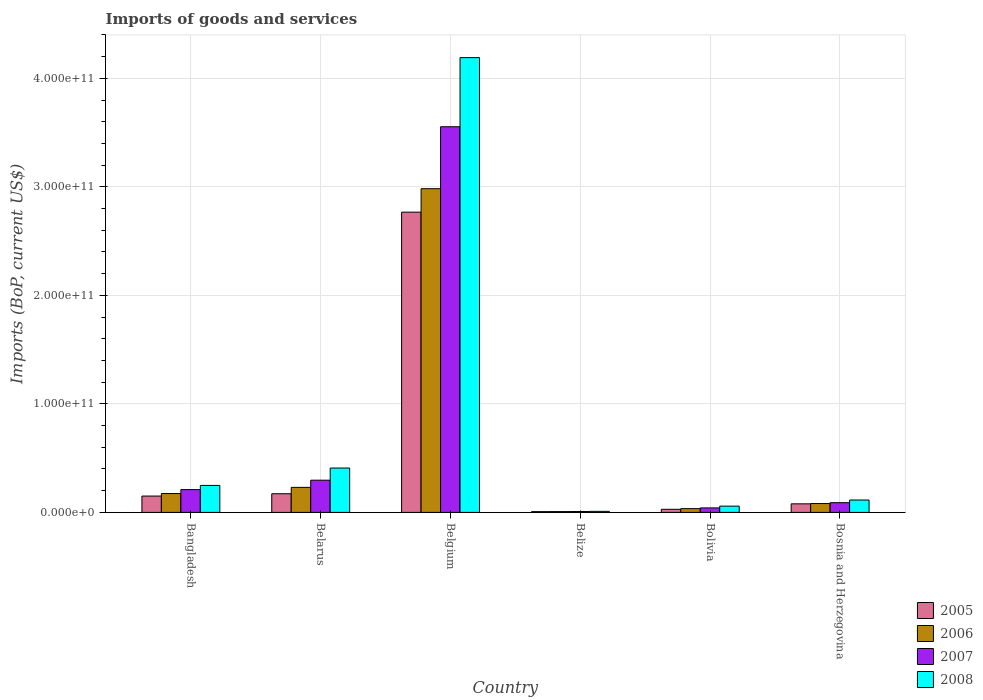How many different coloured bars are there?
Offer a very short reply. 4. Are the number of bars per tick equal to the number of legend labels?
Give a very brief answer. Yes. In how many cases, is the number of bars for a given country not equal to the number of legend labels?
Offer a very short reply. 0. What is the amount spent on imports in 2008 in Belize?
Offer a very short reply. 9.58e+08. Across all countries, what is the maximum amount spent on imports in 2008?
Offer a terse response. 4.19e+11. Across all countries, what is the minimum amount spent on imports in 2005?
Ensure brevity in your answer.  7.03e+08. In which country was the amount spent on imports in 2007 minimum?
Your answer should be compact. Belize. What is the total amount spent on imports in 2008 in the graph?
Provide a succinct answer. 5.03e+11. What is the difference between the amount spent on imports in 2008 in Bangladesh and that in Bolivia?
Your response must be concise. 1.91e+1. What is the difference between the amount spent on imports in 2008 in Bosnia and Herzegovina and the amount spent on imports in 2007 in Belgium?
Give a very brief answer. -3.44e+11. What is the average amount spent on imports in 2006 per country?
Offer a very short reply. 5.85e+1. What is the difference between the amount spent on imports of/in 2007 and amount spent on imports of/in 2008 in Bosnia and Herzegovina?
Your answer should be compact. -2.45e+09. What is the ratio of the amount spent on imports in 2006 in Belgium to that in Bolivia?
Make the answer very short. 86.29. Is the difference between the amount spent on imports in 2007 in Bolivia and Bosnia and Herzegovina greater than the difference between the amount spent on imports in 2008 in Bolivia and Bosnia and Herzegovina?
Your answer should be very brief. Yes. What is the difference between the highest and the second highest amount spent on imports in 2005?
Give a very brief answer. 2.62e+11. What is the difference between the highest and the lowest amount spent on imports in 2007?
Make the answer very short. 3.55e+11. Is it the case that in every country, the sum of the amount spent on imports in 2005 and amount spent on imports in 2006 is greater than the sum of amount spent on imports in 2008 and amount spent on imports in 2007?
Offer a terse response. No. What does the 2nd bar from the left in Belarus represents?
Provide a short and direct response. 2006. What does the 3rd bar from the right in Belgium represents?
Give a very brief answer. 2006. How many bars are there?
Give a very brief answer. 24. Are all the bars in the graph horizontal?
Your answer should be compact. No. What is the difference between two consecutive major ticks on the Y-axis?
Your response must be concise. 1.00e+11. How are the legend labels stacked?
Provide a succinct answer. Vertical. What is the title of the graph?
Offer a terse response. Imports of goods and services. Does "2014" appear as one of the legend labels in the graph?
Provide a short and direct response. No. What is the label or title of the Y-axis?
Provide a short and direct response. Imports (BoP, current US$). What is the Imports (BoP, current US$) in 2005 in Bangladesh?
Provide a short and direct response. 1.51e+1. What is the Imports (BoP, current US$) in 2006 in Bangladesh?
Offer a very short reply. 1.74e+1. What is the Imports (BoP, current US$) of 2007 in Bangladesh?
Give a very brief answer. 2.10e+1. What is the Imports (BoP, current US$) in 2008 in Bangladesh?
Offer a very short reply. 2.49e+1. What is the Imports (BoP, current US$) of 2005 in Belarus?
Provide a succinct answer. 1.72e+1. What is the Imports (BoP, current US$) of 2006 in Belarus?
Provide a succinct answer. 2.31e+1. What is the Imports (BoP, current US$) in 2007 in Belarus?
Your response must be concise. 2.97e+1. What is the Imports (BoP, current US$) in 2008 in Belarus?
Offer a terse response. 4.09e+1. What is the Imports (BoP, current US$) in 2005 in Belgium?
Offer a very short reply. 2.77e+11. What is the Imports (BoP, current US$) of 2006 in Belgium?
Your answer should be compact. 2.98e+11. What is the Imports (BoP, current US$) of 2007 in Belgium?
Give a very brief answer. 3.55e+11. What is the Imports (BoP, current US$) of 2008 in Belgium?
Your answer should be compact. 4.19e+11. What is the Imports (BoP, current US$) in 2005 in Belize?
Your response must be concise. 7.03e+08. What is the Imports (BoP, current US$) in 2006 in Belize?
Your answer should be very brief. 7.50e+08. What is the Imports (BoP, current US$) of 2007 in Belize?
Your response must be concise. 8.03e+08. What is the Imports (BoP, current US$) of 2008 in Belize?
Provide a succinct answer. 9.58e+08. What is the Imports (BoP, current US$) in 2005 in Bolivia?
Offer a terse response. 2.86e+09. What is the Imports (BoP, current US$) of 2006 in Bolivia?
Ensure brevity in your answer.  3.46e+09. What is the Imports (BoP, current US$) of 2007 in Bolivia?
Offer a terse response. 4.14e+09. What is the Imports (BoP, current US$) of 2008 in Bolivia?
Your answer should be very brief. 5.78e+09. What is the Imports (BoP, current US$) of 2005 in Bosnia and Herzegovina?
Provide a short and direct response. 7.89e+09. What is the Imports (BoP, current US$) of 2006 in Bosnia and Herzegovina?
Provide a succinct answer. 8.15e+09. What is the Imports (BoP, current US$) in 2007 in Bosnia and Herzegovina?
Keep it short and to the point. 8.95e+09. What is the Imports (BoP, current US$) in 2008 in Bosnia and Herzegovina?
Your answer should be very brief. 1.14e+1. Across all countries, what is the maximum Imports (BoP, current US$) of 2005?
Offer a very short reply. 2.77e+11. Across all countries, what is the maximum Imports (BoP, current US$) in 2006?
Provide a succinct answer. 2.98e+11. Across all countries, what is the maximum Imports (BoP, current US$) in 2007?
Your answer should be compact. 3.55e+11. Across all countries, what is the maximum Imports (BoP, current US$) of 2008?
Give a very brief answer. 4.19e+11. Across all countries, what is the minimum Imports (BoP, current US$) of 2005?
Ensure brevity in your answer.  7.03e+08. Across all countries, what is the minimum Imports (BoP, current US$) in 2006?
Offer a terse response. 7.50e+08. Across all countries, what is the minimum Imports (BoP, current US$) in 2007?
Keep it short and to the point. 8.03e+08. Across all countries, what is the minimum Imports (BoP, current US$) of 2008?
Ensure brevity in your answer.  9.58e+08. What is the total Imports (BoP, current US$) in 2005 in the graph?
Provide a succinct answer. 3.20e+11. What is the total Imports (BoP, current US$) in 2006 in the graph?
Provide a short and direct response. 3.51e+11. What is the total Imports (BoP, current US$) of 2007 in the graph?
Offer a very short reply. 4.20e+11. What is the total Imports (BoP, current US$) of 2008 in the graph?
Provide a succinct answer. 5.03e+11. What is the difference between the Imports (BoP, current US$) in 2005 in Bangladesh and that in Belarus?
Keep it short and to the point. -2.14e+09. What is the difference between the Imports (BoP, current US$) in 2006 in Bangladesh and that in Belarus?
Offer a terse response. -5.69e+09. What is the difference between the Imports (BoP, current US$) in 2007 in Bangladesh and that in Belarus?
Ensure brevity in your answer.  -8.66e+09. What is the difference between the Imports (BoP, current US$) in 2008 in Bangladesh and that in Belarus?
Keep it short and to the point. -1.60e+1. What is the difference between the Imports (BoP, current US$) of 2005 in Bangladesh and that in Belgium?
Give a very brief answer. -2.62e+11. What is the difference between the Imports (BoP, current US$) of 2006 in Bangladesh and that in Belgium?
Your response must be concise. -2.81e+11. What is the difference between the Imports (BoP, current US$) in 2007 in Bangladesh and that in Belgium?
Ensure brevity in your answer.  -3.34e+11. What is the difference between the Imports (BoP, current US$) of 2008 in Bangladesh and that in Belgium?
Offer a terse response. -3.94e+11. What is the difference between the Imports (BoP, current US$) in 2005 in Bangladesh and that in Belize?
Keep it short and to the point. 1.44e+1. What is the difference between the Imports (BoP, current US$) in 2006 in Bangladesh and that in Belize?
Your answer should be very brief. 1.66e+1. What is the difference between the Imports (BoP, current US$) in 2007 in Bangladesh and that in Belize?
Provide a short and direct response. 2.02e+1. What is the difference between the Imports (BoP, current US$) in 2008 in Bangladesh and that in Belize?
Make the answer very short. 2.39e+1. What is the difference between the Imports (BoP, current US$) in 2005 in Bangladesh and that in Bolivia?
Give a very brief answer. 1.22e+1. What is the difference between the Imports (BoP, current US$) of 2006 in Bangladesh and that in Bolivia?
Make the answer very short. 1.39e+1. What is the difference between the Imports (BoP, current US$) in 2007 in Bangladesh and that in Bolivia?
Your answer should be compact. 1.69e+1. What is the difference between the Imports (BoP, current US$) of 2008 in Bangladesh and that in Bolivia?
Offer a terse response. 1.91e+1. What is the difference between the Imports (BoP, current US$) of 2005 in Bangladesh and that in Bosnia and Herzegovina?
Provide a succinct answer. 7.17e+09. What is the difference between the Imports (BoP, current US$) in 2006 in Bangladesh and that in Bosnia and Herzegovina?
Your response must be concise. 9.22e+09. What is the difference between the Imports (BoP, current US$) in 2007 in Bangladesh and that in Bosnia and Herzegovina?
Your answer should be compact. 1.21e+1. What is the difference between the Imports (BoP, current US$) of 2008 in Bangladesh and that in Bosnia and Herzegovina?
Provide a succinct answer. 1.35e+1. What is the difference between the Imports (BoP, current US$) of 2005 in Belarus and that in Belgium?
Provide a succinct answer. -2.59e+11. What is the difference between the Imports (BoP, current US$) of 2006 in Belarus and that in Belgium?
Offer a terse response. -2.75e+11. What is the difference between the Imports (BoP, current US$) of 2007 in Belarus and that in Belgium?
Give a very brief answer. -3.26e+11. What is the difference between the Imports (BoP, current US$) in 2008 in Belarus and that in Belgium?
Ensure brevity in your answer.  -3.78e+11. What is the difference between the Imports (BoP, current US$) of 2005 in Belarus and that in Belize?
Provide a succinct answer. 1.65e+1. What is the difference between the Imports (BoP, current US$) in 2006 in Belarus and that in Belize?
Your response must be concise. 2.23e+1. What is the difference between the Imports (BoP, current US$) of 2007 in Belarus and that in Belize?
Your answer should be compact. 2.89e+1. What is the difference between the Imports (BoP, current US$) in 2008 in Belarus and that in Belize?
Make the answer very short. 3.99e+1. What is the difference between the Imports (BoP, current US$) of 2005 in Belarus and that in Bolivia?
Provide a succinct answer. 1.43e+1. What is the difference between the Imports (BoP, current US$) in 2006 in Belarus and that in Bolivia?
Your response must be concise. 1.96e+1. What is the difference between the Imports (BoP, current US$) in 2007 in Belarus and that in Bolivia?
Keep it short and to the point. 2.55e+1. What is the difference between the Imports (BoP, current US$) of 2008 in Belarus and that in Bolivia?
Ensure brevity in your answer.  3.51e+1. What is the difference between the Imports (BoP, current US$) of 2005 in Belarus and that in Bosnia and Herzegovina?
Keep it short and to the point. 9.30e+09. What is the difference between the Imports (BoP, current US$) in 2006 in Belarus and that in Bosnia and Herzegovina?
Give a very brief answer. 1.49e+1. What is the difference between the Imports (BoP, current US$) of 2007 in Belarus and that in Bosnia and Herzegovina?
Offer a terse response. 2.07e+1. What is the difference between the Imports (BoP, current US$) in 2008 in Belarus and that in Bosnia and Herzegovina?
Give a very brief answer. 2.95e+1. What is the difference between the Imports (BoP, current US$) of 2005 in Belgium and that in Belize?
Your response must be concise. 2.76e+11. What is the difference between the Imports (BoP, current US$) of 2006 in Belgium and that in Belize?
Offer a terse response. 2.98e+11. What is the difference between the Imports (BoP, current US$) in 2007 in Belgium and that in Belize?
Your answer should be compact. 3.55e+11. What is the difference between the Imports (BoP, current US$) in 2008 in Belgium and that in Belize?
Keep it short and to the point. 4.18e+11. What is the difference between the Imports (BoP, current US$) of 2005 in Belgium and that in Bolivia?
Your response must be concise. 2.74e+11. What is the difference between the Imports (BoP, current US$) in 2006 in Belgium and that in Bolivia?
Offer a very short reply. 2.95e+11. What is the difference between the Imports (BoP, current US$) in 2007 in Belgium and that in Bolivia?
Your answer should be compact. 3.51e+11. What is the difference between the Imports (BoP, current US$) in 2008 in Belgium and that in Bolivia?
Offer a very short reply. 4.13e+11. What is the difference between the Imports (BoP, current US$) in 2005 in Belgium and that in Bosnia and Herzegovina?
Give a very brief answer. 2.69e+11. What is the difference between the Imports (BoP, current US$) in 2006 in Belgium and that in Bosnia and Herzegovina?
Your answer should be compact. 2.90e+11. What is the difference between the Imports (BoP, current US$) of 2007 in Belgium and that in Bosnia and Herzegovina?
Your answer should be very brief. 3.46e+11. What is the difference between the Imports (BoP, current US$) of 2008 in Belgium and that in Bosnia and Herzegovina?
Give a very brief answer. 4.08e+11. What is the difference between the Imports (BoP, current US$) of 2005 in Belize and that in Bolivia?
Your response must be concise. -2.16e+09. What is the difference between the Imports (BoP, current US$) in 2006 in Belize and that in Bolivia?
Ensure brevity in your answer.  -2.71e+09. What is the difference between the Imports (BoP, current US$) of 2007 in Belize and that in Bolivia?
Keep it short and to the point. -3.34e+09. What is the difference between the Imports (BoP, current US$) in 2008 in Belize and that in Bolivia?
Give a very brief answer. -4.82e+09. What is the difference between the Imports (BoP, current US$) of 2005 in Belize and that in Bosnia and Herzegovina?
Give a very brief answer. -7.19e+09. What is the difference between the Imports (BoP, current US$) in 2006 in Belize and that in Bosnia and Herzegovina?
Give a very brief answer. -7.40e+09. What is the difference between the Imports (BoP, current US$) in 2007 in Belize and that in Bosnia and Herzegovina?
Your response must be concise. -8.15e+09. What is the difference between the Imports (BoP, current US$) in 2008 in Belize and that in Bosnia and Herzegovina?
Your answer should be very brief. -1.04e+1. What is the difference between the Imports (BoP, current US$) in 2005 in Bolivia and that in Bosnia and Herzegovina?
Provide a short and direct response. -5.03e+09. What is the difference between the Imports (BoP, current US$) in 2006 in Bolivia and that in Bosnia and Herzegovina?
Provide a succinct answer. -4.69e+09. What is the difference between the Imports (BoP, current US$) of 2007 in Bolivia and that in Bosnia and Herzegovina?
Offer a very short reply. -4.81e+09. What is the difference between the Imports (BoP, current US$) in 2008 in Bolivia and that in Bosnia and Herzegovina?
Your response must be concise. -5.62e+09. What is the difference between the Imports (BoP, current US$) in 2005 in Bangladesh and the Imports (BoP, current US$) in 2006 in Belarus?
Your answer should be very brief. -8.01e+09. What is the difference between the Imports (BoP, current US$) in 2005 in Bangladesh and the Imports (BoP, current US$) in 2007 in Belarus?
Ensure brevity in your answer.  -1.46e+1. What is the difference between the Imports (BoP, current US$) of 2005 in Bangladesh and the Imports (BoP, current US$) of 2008 in Belarus?
Provide a succinct answer. -2.58e+1. What is the difference between the Imports (BoP, current US$) in 2006 in Bangladesh and the Imports (BoP, current US$) in 2007 in Belarus?
Offer a very short reply. -1.23e+1. What is the difference between the Imports (BoP, current US$) in 2006 in Bangladesh and the Imports (BoP, current US$) in 2008 in Belarus?
Give a very brief answer. -2.35e+1. What is the difference between the Imports (BoP, current US$) in 2007 in Bangladesh and the Imports (BoP, current US$) in 2008 in Belarus?
Offer a very short reply. -1.99e+1. What is the difference between the Imports (BoP, current US$) of 2005 in Bangladesh and the Imports (BoP, current US$) of 2006 in Belgium?
Make the answer very short. -2.83e+11. What is the difference between the Imports (BoP, current US$) in 2005 in Bangladesh and the Imports (BoP, current US$) in 2007 in Belgium?
Offer a very short reply. -3.40e+11. What is the difference between the Imports (BoP, current US$) in 2005 in Bangladesh and the Imports (BoP, current US$) in 2008 in Belgium?
Keep it short and to the point. -4.04e+11. What is the difference between the Imports (BoP, current US$) in 2006 in Bangladesh and the Imports (BoP, current US$) in 2007 in Belgium?
Your answer should be compact. -3.38e+11. What is the difference between the Imports (BoP, current US$) in 2006 in Bangladesh and the Imports (BoP, current US$) in 2008 in Belgium?
Ensure brevity in your answer.  -4.02e+11. What is the difference between the Imports (BoP, current US$) of 2007 in Bangladesh and the Imports (BoP, current US$) of 2008 in Belgium?
Your response must be concise. -3.98e+11. What is the difference between the Imports (BoP, current US$) in 2005 in Bangladesh and the Imports (BoP, current US$) in 2006 in Belize?
Give a very brief answer. 1.43e+1. What is the difference between the Imports (BoP, current US$) in 2005 in Bangladesh and the Imports (BoP, current US$) in 2007 in Belize?
Ensure brevity in your answer.  1.43e+1. What is the difference between the Imports (BoP, current US$) in 2005 in Bangladesh and the Imports (BoP, current US$) in 2008 in Belize?
Offer a terse response. 1.41e+1. What is the difference between the Imports (BoP, current US$) of 2006 in Bangladesh and the Imports (BoP, current US$) of 2007 in Belize?
Give a very brief answer. 1.66e+1. What is the difference between the Imports (BoP, current US$) in 2006 in Bangladesh and the Imports (BoP, current US$) in 2008 in Belize?
Offer a very short reply. 1.64e+1. What is the difference between the Imports (BoP, current US$) in 2007 in Bangladesh and the Imports (BoP, current US$) in 2008 in Belize?
Your answer should be compact. 2.00e+1. What is the difference between the Imports (BoP, current US$) in 2005 in Bangladesh and the Imports (BoP, current US$) in 2006 in Bolivia?
Your answer should be compact. 1.16e+1. What is the difference between the Imports (BoP, current US$) in 2005 in Bangladesh and the Imports (BoP, current US$) in 2007 in Bolivia?
Keep it short and to the point. 1.09e+1. What is the difference between the Imports (BoP, current US$) of 2005 in Bangladesh and the Imports (BoP, current US$) of 2008 in Bolivia?
Your answer should be very brief. 9.28e+09. What is the difference between the Imports (BoP, current US$) of 2006 in Bangladesh and the Imports (BoP, current US$) of 2007 in Bolivia?
Your answer should be compact. 1.32e+1. What is the difference between the Imports (BoP, current US$) of 2006 in Bangladesh and the Imports (BoP, current US$) of 2008 in Bolivia?
Offer a very short reply. 1.16e+1. What is the difference between the Imports (BoP, current US$) in 2007 in Bangladesh and the Imports (BoP, current US$) in 2008 in Bolivia?
Your answer should be very brief. 1.52e+1. What is the difference between the Imports (BoP, current US$) of 2005 in Bangladesh and the Imports (BoP, current US$) of 2006 in Bosnia and Herzegovina?
Provide a succinct answer. 6.91e+09. What is the difference between the Imports (BoP, current US$) of 2005 in Bangladesh and the Imports (BoP, current US$) of 2007 in Bosnia and Herzegovina?
Your response must be concise. 6.11e+09. What is the difference between the Imports (BoP, current US$) in 2005 in Bangladesh and the Imports (BoP, current US$) in 2008 in Bosnia and Herzegovina?
Your response must be concise. 3.66e+09. What is the difference between the Imports (BoP, current US$) in 2006 in Bangladesh and the Imports (BoP, current US$) in 2007 in Bosnia and Herzegovina?
Your answer should be compact. 8.42e+09. What is the difference between the Imports (BoP, current US$) in 2006 in Bangladesh and the Imports (BoP, current US$) in 2008 in Bosnia and Herzegovina?
Provide a short and direct response. 5.97e+09. What is the difference between the Imports (BoP, current US$) of 2007 in Bangladesh and the Imports (BoP, current US$) of 2008 in Bosnia and Herzegovina?
Give a very brief answer. 9.61e+09. What is the difference between the Imports (BoP, current US$) in 2005 in Belarus and the Imports (BoP, current US$) in 2006 in Belgium?
Offer a terse response. -2.81e+11. What is the difference between the Imports (BoP, current US$) of 2005 in Belarus and the Imports (BoP, current US$) of 2007 in Belgium?
Make the answer very short. -3.38e+11. What is the difference between the Imports (BoP, current US$) in 2005 in Belarus and the Imports (BoP, current US$) in 2008 in Belgium?
Keep it short and to the point. -4.02e+11. What is the difference between the Imports (BoP, current US$) of 2006 in Belarus and the Imports (BoP, current US$) of 2007 in Belgium?
Your answer should be compact. -3.32e+11. What is the difference between the Imports (BoP, current US$) of 2006 in Belarus and the Imports (BoP, current US$) of 2008 in Belgium?
Offer a very short reply. -3.96e+11. What is the difference between the Imports (BoP, current US$) in 2007 in Belarus and the Imports (BoP, current US$) in 2008 in Belgium?
Your response must be concise. -3.89e+11. What is the difference between the Imports (BoP, current US$) in 2005 in Belarus and the Imports (BoP, current US$) in 2006 in Belize?
Offer a very short reply. 1.64e+1. What is the difference between the Imports (BoP, current US$) of 2005 in Belarus and the Imports (BoP, current US$) of 2007 in Belize?
Your answer should be compact. 1.64e+1. What is the difference between the Imports (BoP, current US$) of 2005 in Belarus and the Imports (BoP, current US$) of 2008 in Belize?
Your answer should be compact. 1.62e+1. What is the difference between the Imports (BoP, current US$) in 2006 in Belarus and the Imports (BoP, current US$) in 2007 in Belize?
Offer a very short reply. 2.23e+1. What is the difference between the Imports (BoP, current US$) of 2006 in Belarus and the Imports (BoP, current US$) of 2008 in Belize?
Ensure brevity in your answer.  2.21e+1. What is the difference between the Imports (BoP, current US$) in 2007 in Belarus and the Imports (BoP, current US$) in 2008 in Belize?
Offer a terse response. 2.87e+1. What is the difference between the Imports (BoP, current US$) of 2005 in Belarus and the Imports (BoP, current US$) of 2006 in Bolivia?
Your answer should be compact. 1.37e+1. What is the difference between the Imports (BoP, current US$) in 2005 in Belarus and the Imports (BoP, current US$) in 2007 in Bolivia?
Keep it short and to the point. 1.31e+1. What is the difference between the Imports (BoP, current US$) in 2005 in Belarus and the Imports (BoP, current US$) in 2008 in Bolivia?
Your answer should be very brief. 1.14e+1. What is the difference between the Imports (BoP, current US$) of 2006 in Belarus and the Imports (BoP, current US$) of 2007 in Bolivia?
Keep it short and to the point. 1.89e+1. What is the difference between the Imports (BoP, current US$) in 2006 in Belarus and the Imports (BoP, current US$) in 2008 in Bolivia?
Your answer should be compact. 1.73e+1. What is the difference between the Imports (BoP, current US$) in 2007 in Belarus and the Imports (BoP, current US$) in 2008 in Bolivia?
Provide a succinct answer. 2.39e+1. What is the difference between the Imports (BoP, current US$) in 2005 in Belarus and the Imports (BoP, current US$) in 2006 in Bosnia and Herzegovina?
Offer a very short reply. 9.05e+09. What is the difference between the Imports (BoP, current US$) in 2005 in Belarus and the Imports (BoP, current US$) in 2007 in Bosnia and Herzegovina?
Provide a short and direct response. 8.25e+09. What is the difference between the Imports (BoP, current US$) in 2005 in Belarus and the Imports (BoP, current US$) in 2008 in Bosnia and Herzegovina?
Provide a short and direct response. 5.80e+09. What is the difference between the Imports (BoP, current US$) in 2006 in Belarus and the Imports (BoP, current US$) in 2007 in Bosnia and Herzegovina?
Offer a terse response. 1.41e+1. What is the difference between the Imports (BoP, current US$) of 2006 in Belarus and the Imports (BoP, current US$) of 2008 in Bosnia and Herzegovina?
Offer a very short reply. 1.17e+1. What is the difference between the Imports (BoP, current US$) of 2007 in Belarus and the Imports (BoP, current US$) of 2008 in Bosnia and Herzegovina?
Your response must be concise. 1.83e+1. What is the difference between the Imports (BoP, current US$) of 2005 in Belgium and the Imports (BoP, current US$) of 2006 in Belize?
Make the answer very short. 2.76e+11. What is the difference between the Imports (BoP, current US$) of 2005 in Belgium and the Imports (BoP, current US$) of 2007 in Belize?
Keep it short and to the point. 2.76e+11. What is the difference between the Imports (BoP, current US$) of 2005 in Belgium and the Imports (BoP, current US$) of 2008 in Belize?
Give a very brief answer. 2.76e+11. What is the difference between the Imports (BoP, current US$) in 2006 in Belgium and the Imports (BoP, current US$) in 2007 in Belize?
Your answer should be compact. 2.97e+11. What is the difference between the Imports (BoP, current US$) of 2006 in Belgium and the Imports (BoP, current US$) of 2008 in Belize?
Your response must be concise. 2.97e+11. What is the difference between the Imports (BoP, current US$) in 2007 in Belgium and the Imports (BoP, current US$) in 2008 in Belize?
Your answer should be very brief. 3.54e+11. What is the difference between the Imports (BoP, current US$) of 2005 in Belgium and the Imports (BoP, current US$) of 2006 in Bolivia?
Offer a terse response. 2.73e+11. What is the difference between the Imports (BoP, current US$) of 2005 in Belgium and the Imports (BoP, current US$) of 2007 in Bolivia?
Offer a terse response. 2.73e+11. What is the difference between the Imports (BoP, current US$) of 2005 in Belgium and the Imports (BoP, current US$) of 2008 in Bolivia?
Offer a very short reply. 2.71e+11. What is the difference between the Imports (BoP, current US$) of 2006 in Belgium and the Imports (BoP, current US$) of 2007 in Bolivia?
Ensure brevity in your answer.  2.94e+11. What is the difference between the Imports (BoP, current US$) in 2006 in Belgium and the Imports (BoP, current US$) in 2008 in Bolivia?
Provide a succinct answer. 2.93e+11. What is the difference between the Imports (BoP, current US$) in 2007 in Belgium and the Imports (BoP, current US$) in 2008 in Bolivia?
Your response must be concise. 3.50e+11. What is the difference between the Imports (BoP, current US$) in 2005 in Belgium and the Imports (BoP, current US$) in 2006 in Bosnia and Herzegovina?
Provide a succinct answer. 2.69e+11. What is the difference between the Imports (BoP, current US$) in 2005 in Belgium and the Imports (BoP, current US$) in 2007 in Bosnia and Herzegovina?
Make the answer very short. 2.68e+11. What is the difference between the Imports (BoP, current US$) of 2005 in Belgium and the Imports (BoP, current US$) of 2008 in Bosnia and Herzegovina?
Make the answer very short. 2.65e+11. What is the difference between the Imports (BoP, current US$) in 2006 in Belgium and the Imports (BoP, current US$) in 2007 in Bosnia and Herzegovina?
Your response must be concise. 2.89e+11. What is the difference between the Imports (BoP, current US$) of 2006 in Belgium and the Imports (BoP, current US$) of 2008 in Bosnia and Herzegovina?
Provide a succinct answer. 2.87e+11. What is the difference between the Imports (BoP, current US$) of 2007 in Belgium and the Imports (BoP, current US$) of 2008 in Bosnia and Herzegovina?
Your answer should be compact. 3.44e+11. What is the difference between the Imports (BoP, current US$) in 2005 in Belize and the Imports (BoP, current US$) in 2006 in Bolivia?
Offer a very short reply. -2.75e+09. What is the difference between the Imports (BoP, current US$) of 2005 in Belize and the Imports (BoP, current US$) of 2007 in Bolivia?
Provide a succinct answer. -3.44e+09. What is the difference between the Imports (BoP, current US$) of 2005 in Belize and the Imports (BoP, current US$) of 2008 in Bolivia?
Offer a very short reply. -5.08e+09. What is the difference between the Imports (BoP, current US$) of 2006 in Belize and the Imports (BoP, current US$) of 2007 in Bolivia?
Ensure brevity in your answer.  -3.39e+09. What is the difference between the Imports (BoP, current US$) of 2006 in Belize and the Imports (BoP, current US$) of 2008 in Bolivia?
Your answer should be compact. -5.03e+09. What is the difference between the Imports (BoP, current US$) of 2007 in Belize and the Imports (BoP, current US$) of 2008 in Bolivia?
Ensure brevity in your answer.  -4.98e+09. What is the difference between the Imports (BoP, current US$) in 2005 in Belize and the Imports (BoP, current US$) in 2006 in Bosnia and Herzegovina?
Offer a very short reply. -7.44e+09. What is the difference between the Imports (BoP, current US$) of 2005 in Belize and the Imports (BoP, current US$) of 2007 in Bosnia and Herzegovina?
Offer a terse response. -8.25e+09. What is the difference between the Imports (BoP, current US$) in 2005 in Belize and the Imports (BoP, current US$) in 2008 in Bosnia and Herzegovina?
Provide a short and direct response. -1.07e+1. What is the difference between the Imports (BoP, current US$) of 2006 in Belize and the Imports (BoP, current US$) of 2007 in Bosnia and Herzegovina?
Your response must be concise. -8.20e+09. What is the difference between the Imports (BoP, current US$) in 2006 in Belize and the Imports (BoP, current US$) in 2008 in Bosnia and Herzegovina?
Offer a very short reply. -1.06e+1. What is the difference between the Imports (BoP, current US$) in 2007 in Belize and the Imports (BoP, current US$) in 2008 in Bosnia and Herzegovina?
Offer a very short reply. -1.06e+1. What is the difference between the Imports (BoP, current US$) of 2005 in Bolivia and the Imports (BoP, current US$) of 2006 in Bosnia and Herzegovina?
Give a very brief answer. -5.28e+09. What is the difference between the Imports (BoP, current US$) in 2005 in Bolivia and the Imports (BoP, current US$) in 2007 in Bosnia and Herzegovina?
Keep it short and to the point. -6.09e+09. What is the difference between the Imports (BoP, current US$) in 2005 in Bolivia and the Imports (BoP, current US$) in 2008 in Bosnia and Herzegovina?
Your answer should be compact. -8.53e+09. What is the difference between the Imports (BoP, current US$) in 2006 in Bolivia and the Imports (BoP, current US$) in 2007 in Bosnia and Herzegovina?
Make the answer very short. -5.49e+09. What is the difference between the Imports (BoP, current US$) in 2006 in Bolivia and the Imports (BoP, current US$) in 2008 in Bosnia and Herzegovina?
Your answer should be very brief. -7.94e+09. What is the difference between the Imports (BoP, current US$) in 2007 in Bolivia and the Imports (BoP, current US$) in 2008 in Bosnia and Herzegovina?
Make the answer very short. -7.26e+09. What is the average Imports (BoP, current US$) of 2005 per country?
Provide a succinct answer. 5.34e+1. What is the average Imports (BoP, current US$) of 2006 per country?
Your answer should be compact. 5.85e+1. What is the average Imports (BoP, current US$) in 2007 per country?
Offer a terse response. 7.00e+1. What is the average Imports (BoP, current US$) in 2008 per country?
Make the answer very short. 8.38e+1. What is the difference between the Imports (BoP, current US$) of 2005 and Imports (BoP, current US$) of 2006 in Bangladesh?
Provide a short and direct response. -2.31e+09. What is the difference between the Imports (BoP, current US$) of 2005 and Imports (BoP, current US$) of 2007 in Bangladesh?
Make the answer very short. -5.95e+09. What is the difference between the Imports (BoP, current US$) in 2005 and Imports (BoP, current US$) in 2008 in Bangladesh?
Give a very brief answer. -9.81e+09. What is the difference between the Imports (BoP, current US$) of 2006 and Imports (BoP, current US$) of 2007 in Bangladesh?
Offer a very short reply. -3.64e+09. What is the difference between the Imports (BoP, current US$) in 2006 and Imports (BoP, current US$) in 2008 in Bangladesh?
Provide a succinct answer. -7.50e+09. What is the difference between the Imports (BoP, current US$) of 2007 and Imports (BoP, current US$) of 2008 in Bangladesh?
Give a very brief answer. -3.86e+09. What is the difference between the Imports (BoP, current US$) in 2005 and Imports (BoP, current US$) in 2006 in Belarus?
Offer a terse response. -5.87e+09. What is the difference between the Imports (BoP, current US$) of 2005 and Imports (BoP, current US$) of 2007 in Belarus?
Give a very brief answer. -1.25e+1. What is the difference between the Imports (BoP, current US$) in 2005 and Imports (BoP, current US$) in 2008 in Belarus?
Your answer should be compact. -2.37e+1. What is the difference between the Imports (BoP, current US$) of 2006 and Imports (BoP, current US$) of 2007 in Belarus?
Your answer should be compact. -6.61e+09. What is the difference between the Imports (BoP, current US$) of 2006 and Imports (BoP, current US$) of 2008 in Belarus?
Provide a succinct answer. -1.78e+1. What is the difference between the Imports (BoP, current US$) of 2007 and Imports (BoP, current US$) of 2008 in Belarus?
Offer a terse response. -1.12e+1. What is the difference between the Imports (BoP, current US$) of 2005 and Imports (BoP, current US$) of 2006 in Belgium?
Offer a terse response. -2.16e+1. What is the difference between the Imports (BoP, current US$) of 2005 and Imports (BoP, current US$) of 2007 in Belgium?
Offer a terse response. -7.87e+1. What is the difference between the Imports (BoP, current US$) in 2005 and Imports (BoP, current US$) in 2008 in Belgium?
Your response must be concise. -1.42e+11. What is the difference between the Imports (BoP, current US$) in 2006 and Imports (BoP, current US$) in 2007 in Belgium?
Your answer should be very brief. -5.71e+1. What is the difference between the Imports (BoP, current US$) of 2006 and Imports (BoP, current US$) of 2008 in Belgium?
Give a very brief answer. -1.21e+11. What is the difference between the Imports (BoP, current US$) in 2007 and Imports (BoP, current US$) in 2008 in Belgium?
Your answer should be very brief. -6.37e+1. What is the difference between the Imports (BoP, current US$) of 2005 and Imports (BoP, current US$) of 2006 in Belize?
Your response must be concise. -4.70e+07. What is the difference between the Imports (BoP, current US$) in 2005 and Imports (BoP, current US$) in 2007 in Belize?
Provide a short and direct response. -9.99e+07. What is the difference between the Imports (BoP, current US$) in 2005 and Imports (BoP, current US$) in 2008 in Belize?
Your answer should be compact. -2.55e+08. What is the difference between the Imports (BoP, current US$) of 2006 and Imports (BoP, current US$) of 2007 in Belize?
Offer a very short reply. -5.28e+07. What is the difference between the Imports (BoP, current US$) of 2006 and Imports (BoP, current US$) of 2008 in Belize?
Keep it short and to the point. -2.08e+08. What is the difference between the Imports (BoP, current US$) in 2007 and Imports (BoP, current US$) in 2008 in Belize?
Your answer should be very brief. -1.55e+08. What is the difference between the Imports (BoP, current US$) of 2005 and Imports (BoP, current US$) of 2006 in Bolivia?
Give a very brief answer. -5.92e+08. What is the difference between the Imports (BoP, current US$) in 2005 and Imports (BoP, current US$) in 2007 in Bolivia?
Provide a succinct answer. -1.28e+09. What is the difference between the Imports (BoP, current US$) in 2005 and Imports (BoP, current US$) in 2008 in Bolivia?
Your answer should be compact. -2.91e+09. What is the difference between the Imports (BoP, current US$) in 2006 and Imports (BoP, current US$) in 2007 in Bolivia?
Make the answer very short. -6.83e+08. What is the difference between the Imports (BoP, current US$) of 2006 and Imports (BoP, current US$) of 2008 in Bolivia?
Provide a succinct answer. -2.32e+09. What is the difference between the Imports (BoP, current US$) in 2007 and Imports (BoP, current US$) in 2008 in Bolivia?
Offer a terse response. -1.64e+09. What is the difference between the Imports (BoP, current US$) of 2005 and Imports (BoP, current US$) of 2006 in Bosnia and Herzegovina?
Your answer should be very brief. -2.56e+08. What is the difference between the Imports (BoP, current US$) of 2005 and Imports (BoP, current US$) of 2007 in Bosnia and Herzegovina?
Give a very brief answer. -1.06e+09. What is the difference between the Imports (BoP, current US$) in 2005 and Imports (BoP, current US$) in 2008 in Bosnia and Herzegovina?
Make the answer very short. -3.51e+09. What is the difference between the Imports (BoP, current US$) of 2006 and Imports (BoP, current US$) of 2007 in Bosnia and Herzegovina?
Keep it short and to the point. -8.03e+08. What is the difference between the Imports (BoP, current US$) of 2006 and Imports (BoP, current US$) of 2008 in Bosnia and Herzegovina?
Keep it short and to the point. -3.25e+09. What is the difference between the Imports (BoP, current US$) in 2007 and Imports (BoP, current US$) in 2008 in Bosnia and Herzegovina?
Provide a short and direct response. -2.45e+09. What is the ratio of the Imports (BoP, current US$) in 2005 in Bangladesh to that in Belarus?
Give a very brief answer. 0.88. What is the ratio of the Imports (BoP, current US$) in 2006 in Bangladesh to that in Belarus?
Your answer should be compact. 0.75. What is the ratio of the Imports (BoP, current US$) in 2007 in Bangladesh to that in Belarus?
Keep it short and to the point. 0.71. What is the ratio of the Imports (BoP, current US$) in 2008 in Bangladesh to that in Belarus?
Provide a short and direct response. 0.61. What is the ratio of the Imports (BoP, current US$) of 2005 in Bangladesh to that in Belgium?
Give a very brief answer. 0.05. What is the ratio of the Imports (BoP, current US$) in 2006 in Bangladesh to that in Belgium?
Provide a succinct answer. 0.06. What is the ratio of the Imports (BoP, current US$) of 2007 in Bangladesh to that in Belgium?
Your answer should be compact. 0.06. What is the ratio of the Imports (BoP, current US$) in 2008 in Bangladesh to that in Belgium?
Make the answer very short. 0.06. What is the ratio of the Imports (BoP, current US$) in 2005 in Bangladesh to that in Belize?
Give a very brief answer. 21.42. What is the ratio of the Imports (BoP, current US$) in 2006 in Bangladesh to that in Belize?
Ensure brevity in your answer.  23.16. What is the ratio of the Imports (BoP, current US$) in 2007 in Bangladesh to that in Belize?
Offer a very short reply. 26.16. What is the ratio of the Imports (BoP, current US$) in 2008 in Bangladesh to that in Belize?
Keep it short and to the point. 25.96. What is the ratio of the Imports (BoP, current US$) in 2005 in Bangladesh to that in Bolivia?
Your answer should be compact. 5.26. What is the ratio of the Imports (BoP, current US$) in 2006 in Bangladesh to that in Bolivia?
Provide a short and direct response. 5.02. What is the ratio of the Imports (BoP, current US$) of 2007 in Bangladesh to that in Bolivia?
Make the answer very short. 5.07. What is the ratio of the Imports (BoP, current US$) of 2008 in Bangladesh to that in Bolivia?
Keep it short and to the point. 4.3. What is the ratio of the Imports (BoP, current US$) of 2005 in Bangladesh to that in Bosnia and Herzegovina?
Provide a short and direct response. 1.91. What is the ratio of the Imports (BoP, current US$) in 2006 in Bangladesh to that in Bosnia and Herzegovina?
Offer a very short reply. 2.13. What is the ratio of the Imports (BoP, current US$) in 2007 in Bangladesh to that in Bosnia and Herzegovina?
Ensure brevity in your answer.  2.35. What is the ratio of the Imports (BoP, current US$) of 2008 in Bangladesh to that in Bosnia and Herzegovina?
Your response must be concise. 2.18. What is the ratio of the Imports (BoP, current US$) of 2005 in Belarus to that in Belgium?
Offer a very short reply. 0.06. What is the ratio of the Imports (BoP, current US$) of 2006 in Belarus to that in Belgium?
Your answer should be very brief. 0.08. What is the ratio of the Imports (BoP, current US$) in 2007 in Belarus to that in Belgium?
Offer a terse response. 0.08. What is the ratio of the Imports (BoP, current US$) in 2008 in Belarus to that in Belgium?
Your answer should be very brief. 0.1. What is the ratio of the Imports (BoP, current US$) of 2005 in Belarus to that in Belize?
Offer a very short reply. 24.46. What is the ratio of the Imports (BoP, current US$) in 2006 in Belarus to that in Belize?
Your response must be concise. 30.75. What is the ratio of the Imports (BoP, current US$) in 2007 in Belarus to that in Belize?
Provide a succinct answer. 36.95. What is the ratio of the Imports (BoP, current US$) in 2008 in Belarus to that in Belize?
Provide a succinct answer. 42.67. What is the ratio of the Imports (BoP, current US$) in 2005 in Belarus to that in Bolivia?
Provide a short and direct response. 6. What is the ratio of the Imports (BoP, current US$) in 2006 in Belarus to that in Bolivia?
Give a very brief answer. 6.67. What is the ratio of the Imports (BoP, current US$) of 2007 in Belarus to that in Bolivia?
Offer a very short reply. 7.17. What is the ratio of the Imports (BoP, current US$) of 2008 in Belarus to that in Bolivia?
Offer a very short reply. 7.07. What is the ratio of the Imports (BoP, current US$) in 2005 in Belarus to that in Bosnia and Herzegovina?
Your answer should be compact. 2.18. What is the ratio of the Imports (BoP, current US$) of 2006 in Belarus to that in Bosnia and Herzegovina?
Your response must be concise. 2.83. What is the ratio of the Imports (BoP, current US$) in 2007 in Belarus to that in Bosnia and Herzegovina?
Your answer should be very brief. 3.32. What is the ratio of the Imports (BoP, current US$) in 2008 in Belarus to that in Bosnia and Herzegovina?
Provide a succinct answer. 3.59. What is the ratio of the Imports (BoP, current US$) in 2005 in Belgium to that in Belize?
Keep it short and to the point. 393.56. What is the ratio of the Imports (BoP, current US$) of 2006 in Belgium to that in Belize?
Your answer should be compact. 397.69. What is the ratio of the Imports (BoP, current US$) of 2007 in Belgium to that in Belize?
Keep it short and to the point. 442.64. What is the ratio of the Imports (BoP, current US$) of 2008 in Belgium to that in Belize?
Offer a terse response. 437.54. What is the ratio of the Imports (BoP, current US$) in 2005 in Belgium to that in Bolivia?
Your response must be concise. 96.58. What is the ratio of the Imports (BoP, current US$) of 2006 in Belgium to that in Bolivia?
Offer a terse response. 86.29. What is the ratio of the Imports (BoP, current US$) of 2007 in Belgium to that in Bolivia?
Offer a very short reply. 85.84. What is the ratio of the Imports (BoP, current US$) of 2008 in Belgium to that in Bolivia?
Make the answer very short. 72.53. What is the ratio of the Imports (BoP, current US$) in 2005 in Belgium to that in Bosnia and Herzegovina?
Provide a short and direct response. 35.07. What is the ratio of the Imports (BoP, current US$) of 2006 in Belgium to that in Bosnia and Herzegovina?
Ensure brevity in your answer.  36.62. What is the ratio of the Imports (BoP, current US$) in 2007 in Belgium to that in Bosnia and Herzegovina?
Provide a succinct answer. 39.71. What is the ratio of the Imports (BoP, current US$) in 2008 in Belgium to that in Bosnia and Herzegovina?
Ensure brevity in your answer.  36.77. What is the ratio of the Imports (BoP, current US$) of 2005 in Belize to that in Bolivia?
Provide a short and direct response. 0.25. What is the ratio of the Imports (BoP, current US$) of 2006 in Belize to that in Bolivia?
Keep it short and to the point. 0.22. What is the ratio of the Imports (BoP, current US$) of 2007 in Belize to that in Bolivia?
Your response must be concise. 0.19. What is the ratio of the Imports (BoP, current US$) of 2008 in Belize to that in Bolivia?
Ensure brevity in your answer.  0.17. What is the ratio of the Imports (BoP, current US$) of 2005 in Belize to that in Bosnia and Herzegovina?
Offer a terse response. 0.09. What is the ratio of the Imports (BoP, current US$) of 2006 in Belize to that in Bosnia and Herzegovina?
Provide a short and direct response. 0.09. What is the ratio of the Imports (BoP, current US$) of 2007 in Belize to that in Bosnia and Herzegovina?
Provide a short and direct response. 0.09. What is the ratio of the Imports (BoP, current US$) in 2008 in Belize to that in Bosnia and Herzegovina?
Provide a succinct answer. 0.08. What is the ratio of the Imports (BoP, current US$) in 2005 in Bolivia to that in Bosnia and Herzegovina?
Provide a succinct answer. 0.36. What is the ratio of the Imports (BoP, current US$) in 2006 in Bolivia to that in Bosnia and Herzegovina?
Your answer should be compact. 0.42. What is the ratio of the Imports (BoP, current US$) in 2007 in Bolivia to that in Bosnia and Herzegovina?
Your response must be concise. 0.46. What is the ratio of the Imports (BoP, current US$) of 2008 in Bolivia to that in Bosnia and Herzegovina?
Ensure brevity in your answer.  0.51. What is the difference between the highest and the second highest Imports (BoP, current US$) in 2005?
Make the answer very short. 2.59e+11. What is the difference between the highest and the second highest Imports (BoP, current US$) of 2006?
Keep it short and to the point. 2.75e+11. What is the difference between the highest and the second highest Imports (BoP, current US$) in 2007?
Offer a terse response. 3.26e+11. What is the difference between the highest and the second highest Imports (BoP, current US$) of 2008?
Keep it short and to the point. 3.78e+11. What is the difference between the highest and the lowest Imports (BoP, current US$) of 2005?
Make the answer very short. 2.76e+11. What is the difference between the highest and the lowest Imports (BoP, current US$) of 2006?
Provide a succinct answer. 2.98e+11. What is the difference between the highest and the lowest Imports (BoP, current US$) of 2007?
Your response must be concise. 3.55e+11. What is the difference between the highest and the lowest Imports (BoP, current US$) of 2008?
Provide a succinct answer. 4.18e+11. 